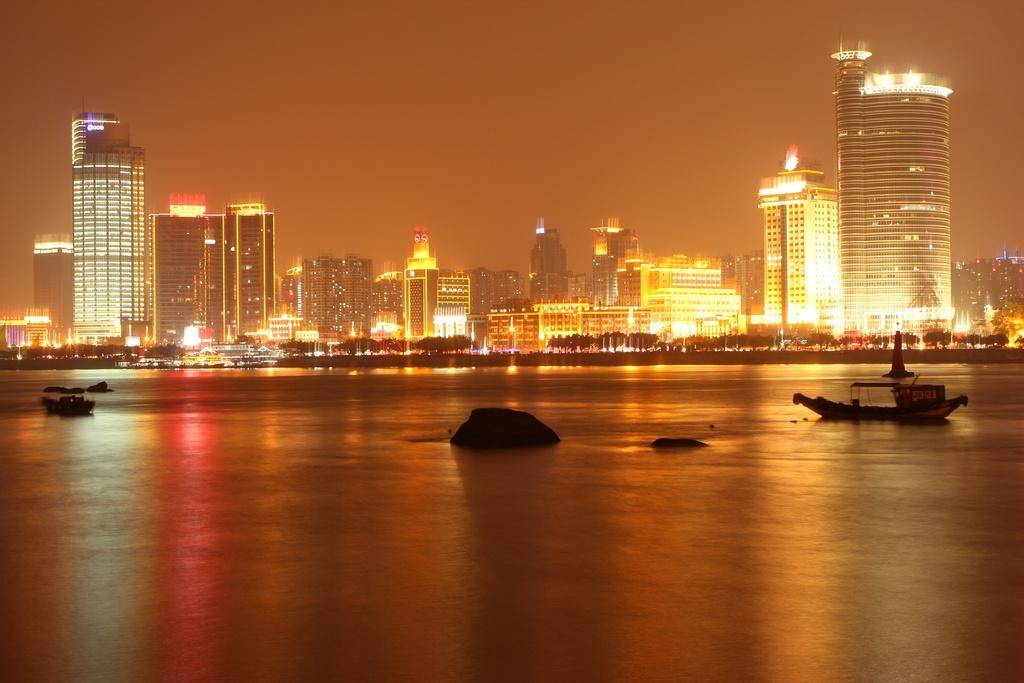Could you give a brief overview of what you see in this image? In this image we can see few boats and rocks in the water. Behind the water we can see a group of trees and buildings. In the buildings we can see the lights. The background of the image is orange. 